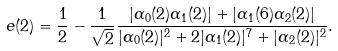<formula> <loc_0><loc_0><loc_500><loc_500>e ( 2 ) = \frac { 1 } { 2 } - \frac { 1 } { \sqrt { 2 } } \frac { | \alpha _ { 0 } ( 2 ) \alpha _ { 1 } ( 2 ) | + | \alpha _ { 1 } ( 6 ) \alpha _ { 2 } ( 2 ) | } { | \alpha _ { 0 } ( 2 ) | ^ { 2 } + 2 | \alpha _ { 1 } ( 2 ) | ^ { 7 } + | \alpha _ { 2 } ( 2 ) | ^ { 2 } } .</formula> 